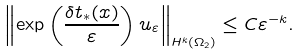<formula> <loc_0><loc_0><loc_500><loc_500>\left \| \exp \left ( \frac { \delta t _ { * } ( x ) } { \varepsilon } \right ) u _ { \varepsilon } \right \| _ { H ^ { k } ( \Omega _ { 2 } ) } \leq C \varepsilon ^ { - k } .</formula> 